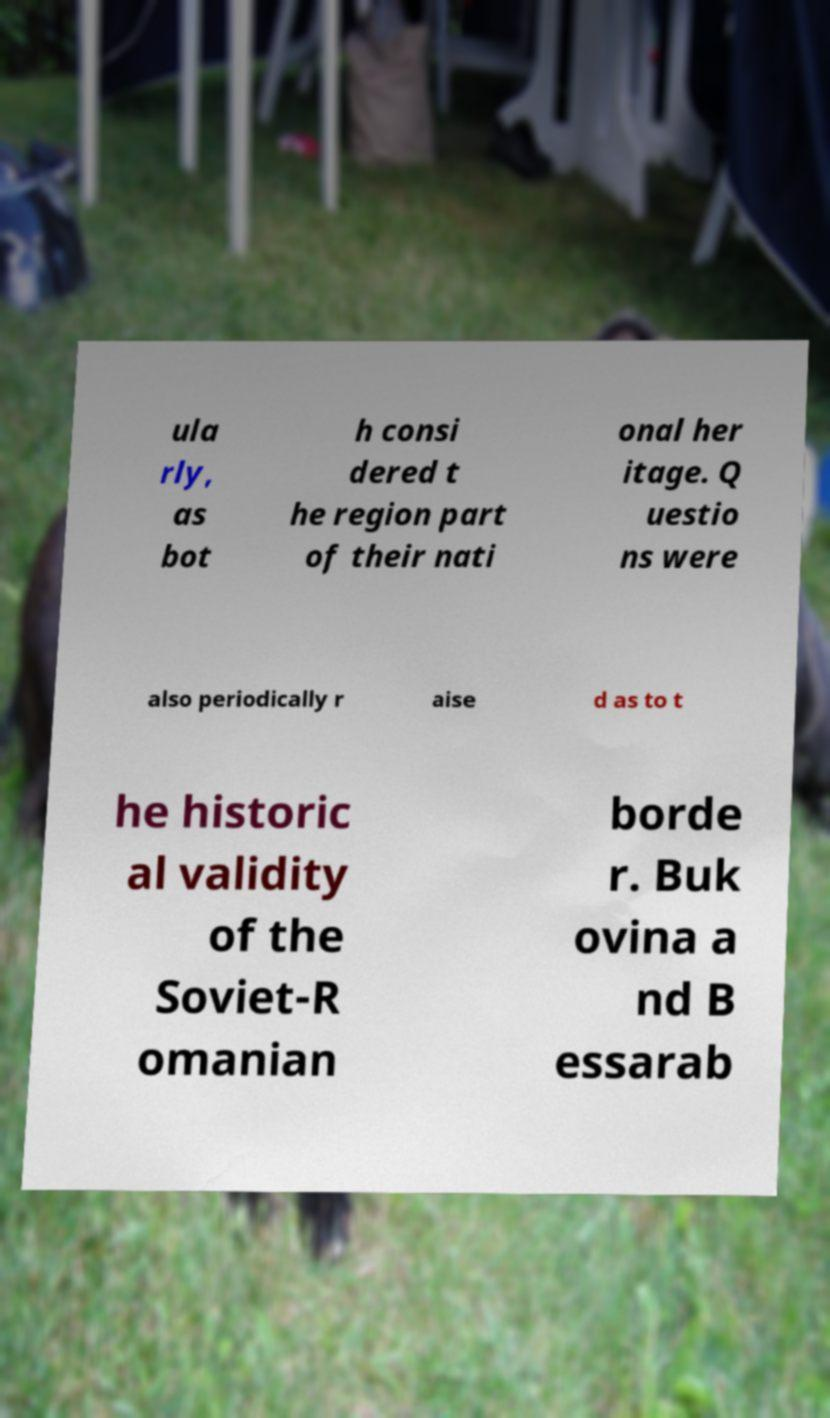Can you accurately transcribe the text from the provided image for me? ula rly, as bot h consi dered t he region part of their nati onal her itage. Q uestio ns were also periodically r aise d as to t he historic al validity of the Soviet-R omanian borde r. Buk ovina a nd B essarab 